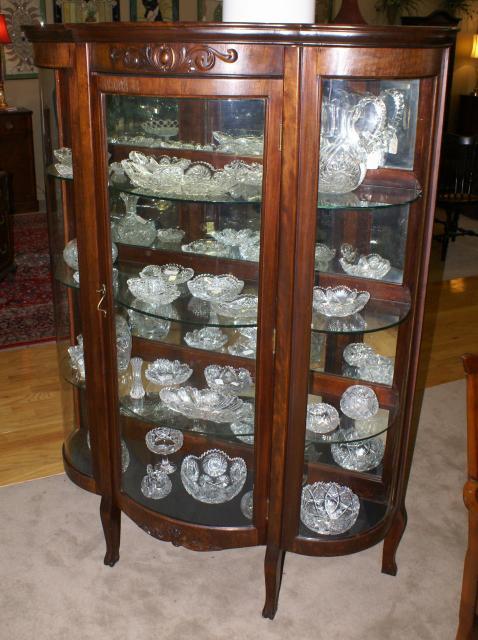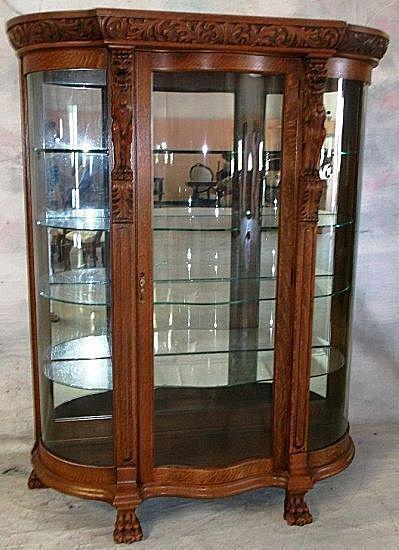The first image is the image on the left, the second image is the image on the right. For the images shown, is this caption "A wood china cupboard in one image has a curved glass front and glass shelves, carving above the door and small feet." true? Answer yes or no. Yes. 